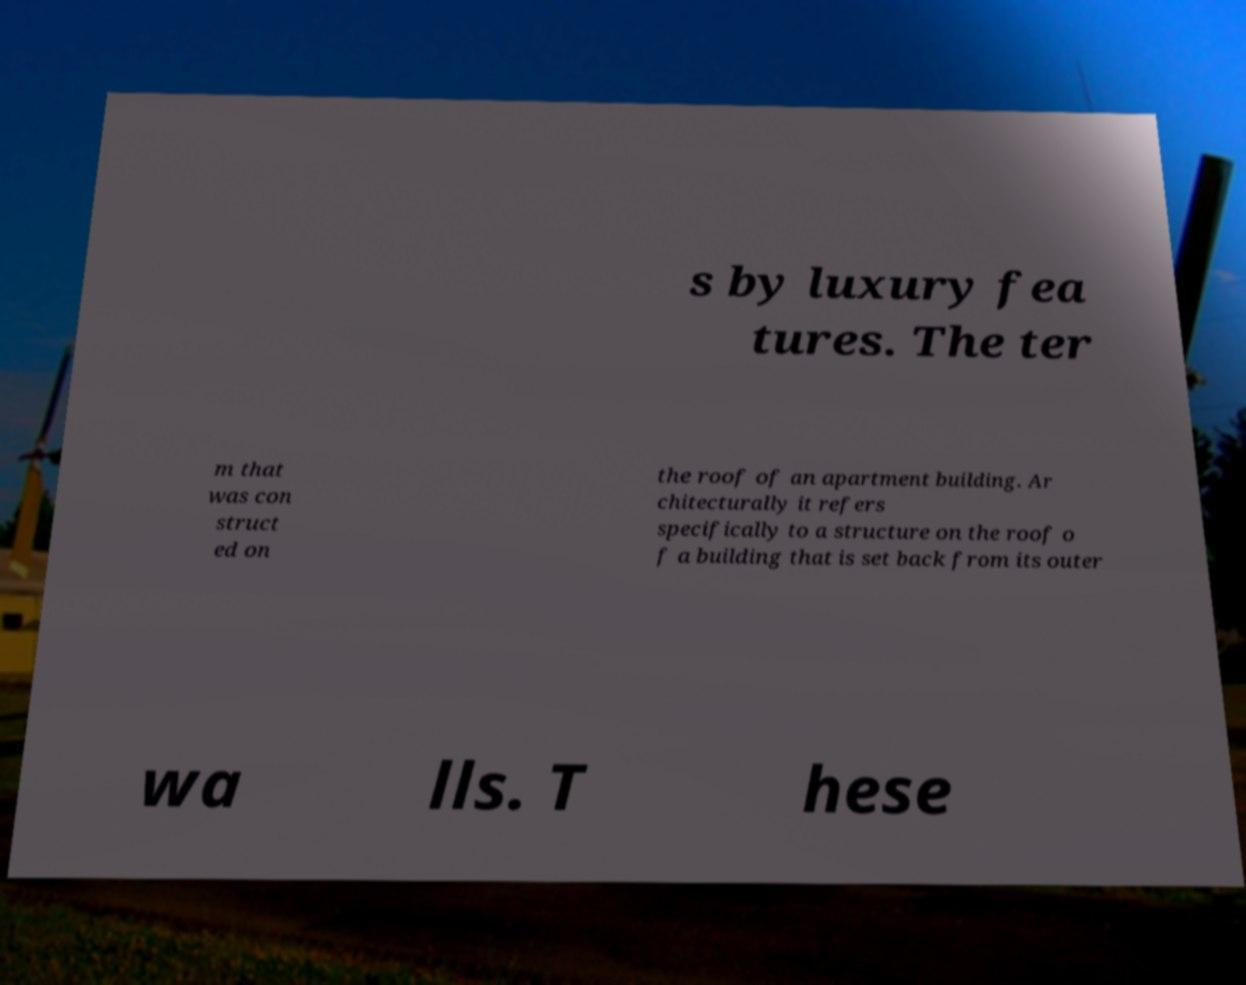Could you extract and type out the text from this image? s by luxury fea tures. The ter m that was con struct ed on the roof of an apartment building. Ar chitecturally it refers specifically to a structure on the roof o f a building that is set back from its outer wa lls. T hese 